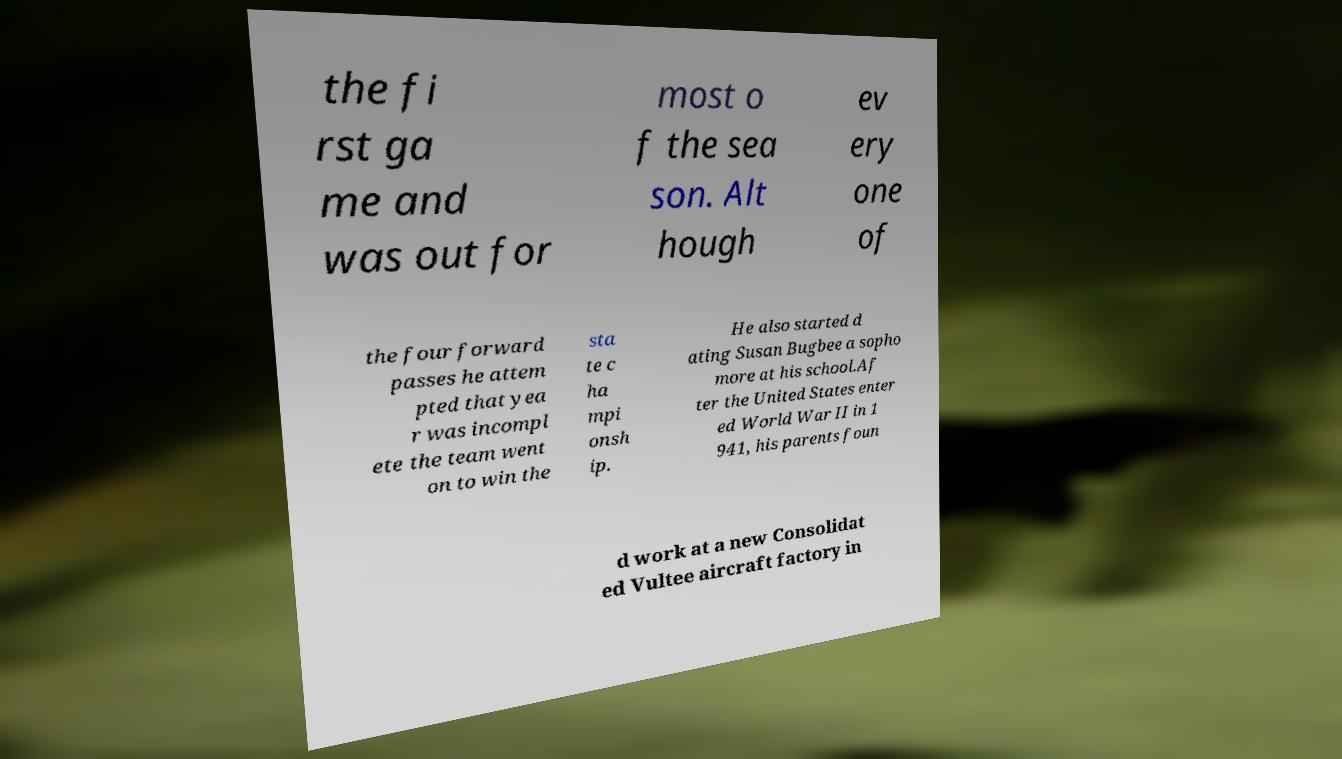Please identify and transcribe the text found in this image. the fi rst ga me and was out for most o f the sea son. Alt hough ev ery one of the four forward passes he attem pted that yea r was incompl ete the team went on to win the sta te c ha mpi onsh ip. He also started d ating Susan Bugbee a sopho more at his school.Af ter the United States enter ed World War II in 1 941, his parents foun d work at a new Consolidat ed Vultee aircraft factory in 